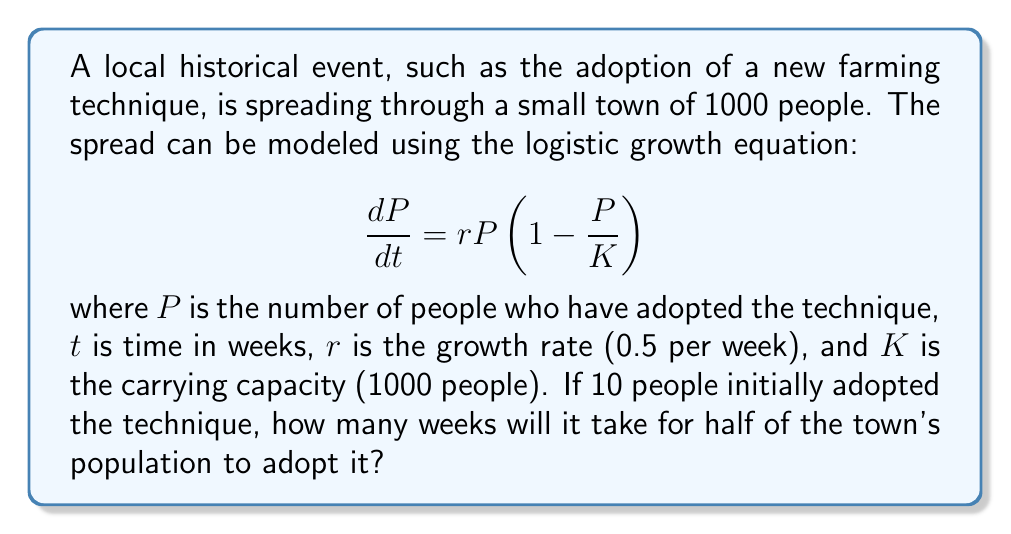What is the answer to this math problem? To solve this problem, we need to use the analytical solution of the logistic growth equation:

$$P(t) = \frac{K}{1 + (\frac{K}{P_0} - 1)e^{-rt}}$$

Where $P_0$ is the initial population that adopted the technique.

Given:
$K = 1000$ (carrying capacity)
$r = 0.5$ per week (growth rate)
$P_0 = 10$ (initial adopters)
$P(t) = 500$ (half of the town's population)

Step 1: Substitute the values into the equation:

$$500 = \frac{1000}{1 + (\frac{1000}{10} - 1)e^{-0.5t}}$$

Step 2: Simplify:

$$500 = \frac{1000}{1 + 99e^{-0.5t}}$$

Step 3: Multiply both sides by the denominator:

$$500(1 + 99e^{-0.5t}) = 1000$$

Step 4: Distribute:

$$500 + 49500e^{-0.5t} = 1000$$

Step 5: Subtract 500 from both sides:

$$49500e^{-0.5t} = 500$$

Step 6: Divide both sides by 49500:

$$e^{-0.5t} = \frac{1}{99}$$

Step 7: Take the natural log of both sides:

$$-0.5t = \ln(\frac{1}{99})$$

Step 8: Solve for t:

$$t = -\frac{2\ln(\frac{1}{99})}{0.5} = 2\ln(99) \approx 9.19$$

Therefore, it will take approximately 9.19 weeks for half of the town's population to adopt the new farming technique.
Answer: 9.19 weeks 